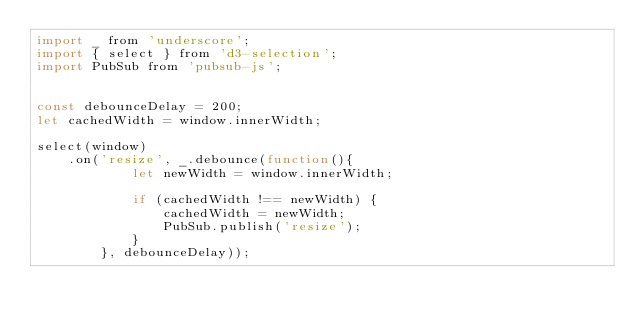Convert code to text. <code><loc_0><loc_0><loc_500><loc_500><_JavaScript_>import _ from 'underscore';
import { select } from 'd3-selection';
import PubSub from 'pubsub-js';


const debounceDelay = 200;
let cachedWidth = window.innerWidth;

select(window)
    .on('resize', _.debounce(function(){
            let newWidth = window.innerWidth;

            if (cachedWidth !== newWidth) {
                cachedWidth = newWidth;
                PubSub.publish('resize');
            }
        }, debounceDelay));
</code> 